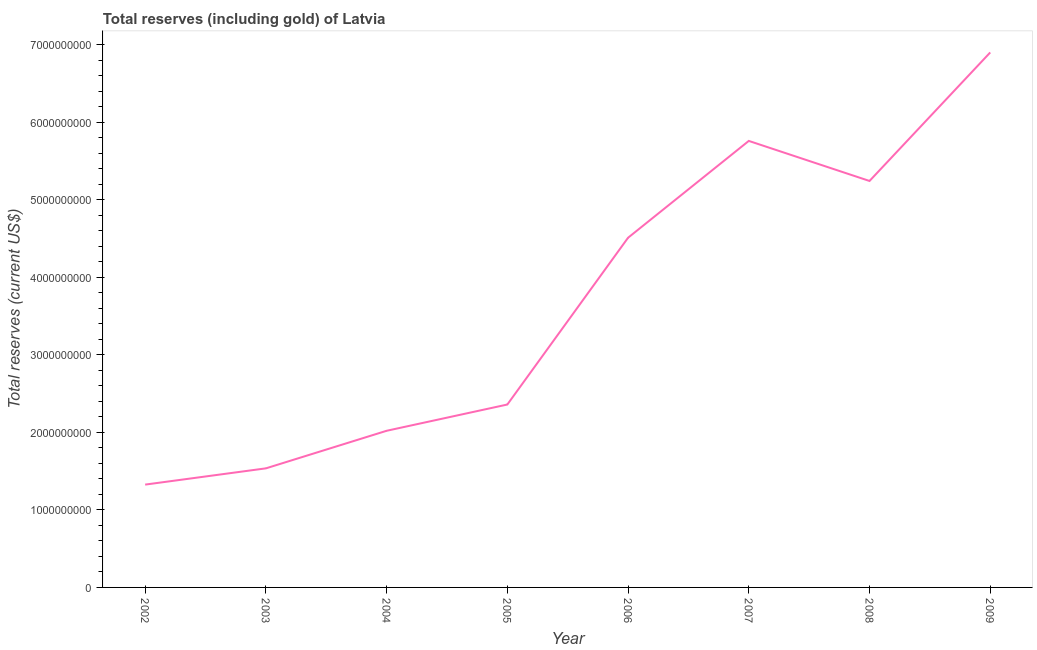What is the total reserves (including gold) in 2009?
Your response must be concise. 6.90e+09. Across all years, what is the maximum total reserves (including gold)?
Give a very brief answer. 6.90e+09. Across all years, what is the minimum total reserves (including gold)?
Your answer should be very brief. 1.33e+09. What is the sum of the total reserves (including gold)?
Provide a succinct answer. 2.97e+1. What is the difference between the total reserves (including gold) in 2003 and 2008?
Provide a succinct answer. -3.71e+09. What is the average total reserves (including gold) per year?
Provide a succinct answer. 3.71e+09. What is the median total reserves (including gold)?
Ensure brevity in your answer.  3.44e+09. In how many years, is the total reserves (including gold) greater than 6800000000 US$?
Your response must be concise. 1. What is the ratio of the total reserves (including gold) in 2004 to that in 2005?
Offer a very short reply. 0.86. What is the difference between the highest and the second highest total reserves (including gold)?
Your answer should be compact. 1.14e+09. Is the sum of the total reserves (including gold) in 2002 and 2006 greater than the maximum total reserves (including gold) across all years?
Make the answer very short. No. What is the difference between the highest and the lowest total reserves (including gold)?
Your answer should be very brief. 5.58e+09. How many lines are there?
Ensure brevity in your answer.  1. How many years are there in the graph?
Give a very brief answer. 8. Does the graph contain any zero values?
Your answer should be very brief. No. What is the title of the graph?
Keep it short and to the point. Total reserves (including gold) of Latvia. What is the label or title of the Y-axis?
Make the answer very short. Total reserves (current US$). What is the Total reserves (current US$) in 2002?
Provide a short and direct response. 1.33e+09. What is the Total reserves (current US$) of 2003?
Your response must be concise. 1.54e+09. What is the Total reserves (current US$) of 2004?
Provide a short and direct response. 2.02e+09. What is the Total reserves (current US$) in 2005?
Offer a very short reply. 2.36e+09. What is the Total reserves (current US$) in 2006?
Provide a succinct answer. 4.51e+09. What is the Total reserves (current US$) in 2007?
Give a very brief answer. 5.76e+09. What is the Total reserves (current US$) of 2008?
Provide a succinct answer. 5.24e+09. What is the Total reserves (current US$) in 2009?
Provide a succinct answer. 6.90e+09. What is the difference between the Total reserves (current US$) in 2002 and 2003?
Give a very brief answer. -2.10e+08. What is the difference between the Total reserves (current US$) in 2002 and 2004?
Offer a terse response. -6.94e+08. What is the difference between the Total reserves (current US$) in 2002 and 2005?
Give a very brief answer. -1.03e+09. What is the difference between the Total reserves (current US$) in 2002 and 2006?
Give a very brief answer. -3.18e+09. What is the difference between the Total reserves (current US$) in 2002 and 2007?
Keep it short and to the point. -4.43e+09. What is the difference between the Total reserves (current US$) in 2002 and 2008?
Offer a terse response. -3.92e+09. What is the difference between the Total reserves (current US$) in 2002 and 2009?
Offer a terse response. -5.58e+09. What is the difference between the Total reserves (current US$) in 2003 and 2004?
Your answer should be compact. -4.85e+08. What is the difference between the Total reserves (current US$) in 2003 and 2005?
Your response must be concise. -8.24e+08. What is the difference between the Total reserves (current US$) in 2003 and 2006?
Offer a terse response. -2.98e+09. What is the difference between the Total reserves (current US$) in 2003 and 2007?
Make the answer very short. -4.22e+09. What is the difference between the Total reserves (current US$) in 2003 and 2008?
Ensure brevity in your answer.  -3.71e+09. What is the difference between the Total reserves (current US$) in 2003 and 2009?
Keep it short and to the point. -5.37e+09. What is the difference between the Total reserves (current US$) in 2004 and 2005?
Provide a succinct answer. -3.39e+08. What is the difference between the Total reserves (current US$) in 2004 and 2006?
Your response must be concise. -2.49e+09. What is the difference between the Total reserves (current US$) in 2004 and 2007?
Give a very brief answer. -3.74e+09. What is the difference between the Total reserves (current US$) in 2004 and 2008?
Make the answer very short. -3.22e+09. What is the difference between the Total reserves (current US$) in 2004 and 2009?
Keep it short and to the point. -4.88e+09. What is the difference between the Total reserves (current US$) in 2005 and 2006?
Provide a short and direct response. -2.15e+09. What is the difference between the Total reserves (current US$) in 2005 and 2007?
Provide a succinct answer. -3.40e+09. What is the difference between the Total reserves (current US$) in 2005 and 2008?
Offer a terse response. -2.88e+09. What is the difference between the Total reserves (current US$) in 2005 and 2009?
Offer a very short reply. -4.54e+09. What is the difference between the Total reserves (current US$) in 2006 and 2007?
Offer a very short reply. -1.25e+09. What is the difference between the Total reserves (current US$) in 2006 and 2008?
Keep it short and to the point. -7.32e+08. What is the difference between the Total reserves (current US$) in 2006 and 2009?
Offer a very short reply. -2.39e+09. What is the difference between the Total reserves (current US$) in 2007 and 2008?
Provide a short and direct response. 5.17e+08. What is the difference between the Total reserves (current US$) in 2007 and 2009?
Your response must be concise. -1.14e+09. What is the difference between the Total reserves (current US$) in 2008 and 2009?
Keep it short and to the point. -1.66e+09. What is the ratio of the Total reserves (current US$) in 2002 to that in 2003?
Your response must be concise. 0.86. What is the ratio of the Total reserves (current US$) in 2002 to that in 2004?
Offer a very short reply. 0.66. What is the ratio of the Total reserves (current US$) in 2002 to that in 2005?
Keep it short and to the point. 0.56. What is the ratio of the Total reserves (current US$) in 2002 to that in 2006?
Provide a short and direct response. 0.29. What is the ratio of the Total reserves (current US$) in 2002 to that in 2007?
Your response must be concise. 0.23. What is the ratio of the Total reserves (current US$) in 2002 to that in 2008?
Provide a short and direct response. 0.25. What is the ratio of the Total reserves (current US$) in 2002 to that in 2009?
Your answer should be very brief. 0.19. What is the ratio of the Total reserves (current US$) in 2003 to that in 2004?
Offer a terse response. 0.76. What is the ratio of the Total reserves (current US$) in 2003 to that in 2005?
Provide a short and direct response. 0.65. What is the ratio of the Total reserves (current US$) in 2003 to that in 2006?
Give a very brief answer. 0.34. What is the ratio of the Total reserves (current US$) in 2003 to that in 2007?
Your response must be concise. 0.27. What is the ratio of the Total reserves (current US$) in 2003 to that in 2008?
Offer a very short reply. 0.29. What is the ratio of the Total reserves (current US$) in 2003 to that in 2009?
Ensure brevity in your answer.  0.22. What is the ratio of the Total reserves (current US$) in 2004 to that in 2005?
Ensure brevity in your answer.  0.86. What is the ratio of the Total reserves (current US$) in 2004 to that in 2006?
Keep it short and to the point. 0.45. What is the ratio of the Total reserves (current US$) in 2004 to that in 2007?
Your answer should be compact. 0.35. What is the ratio of the Total reserves (current US$) in 2004 to that in 2008?
Provide a succinct answer. 0.39. What is the ratio of the Total reserves (current US$) in 2004 to that in 2009?
Make the answer very short. 0.29. What is the ratio of the Total reserves (current US$) in 2005 to that in 2006?
Provide a short and direct response. 0.52. What is the ratio of the Total reserves (current US$) in 2005 to that in 2007?
Offer a terse response. 0.41. What is the ratio of the Total reserves (current US$) in 2005 to that in 2008?
Ensure brevity in your answer.  0.45. What is the ratio of the Total reserves (current US$) in 2005 to that in 2009?
Offer a terse response. 0.34. What is the ratio of the Total reserves (current US$) in 2006 to that in 2007?
Provide a succinct answer. 0.78. What is the ratio of the Total reserves (current US$) in 2006 to that in 2008?
Offer a very short reply. 0.86. What is the ratio of the Total reserves (current US$) in 2006 to that in 2009?
Your response must be concise. 0.65. What is the ratio of the Total reserves (current US$) in 2007 to that in 2008?
Give a very brief answer. 1.1. What is the ratio of the Total reserves (current US$) in 2007 to that in 2009?
Provide a short and direct response. 0.83. What is the ratio of the Total reserves (current US$) in 2008 to that in 2009?
Provide a succinct answer. 0.76. 